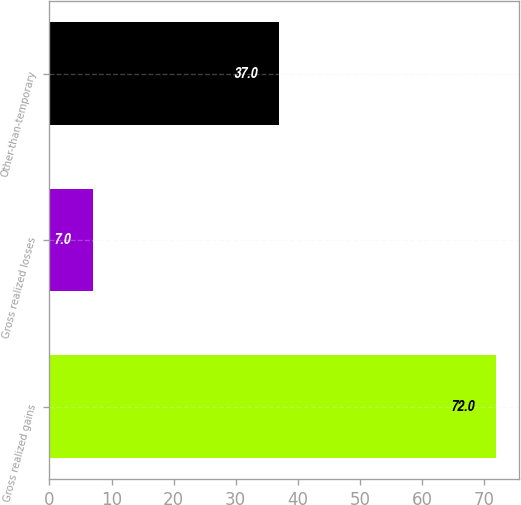Convert chart to OTSL. <chart><loc_0><loc_0><loc_500><loc_500><bar_chart><fcel>Gross realized gains<fcel>Gross realized losses<fcel>Other-than-temporary<nl><fcel>72<fcel>7<fcel>37<nl></chart> 